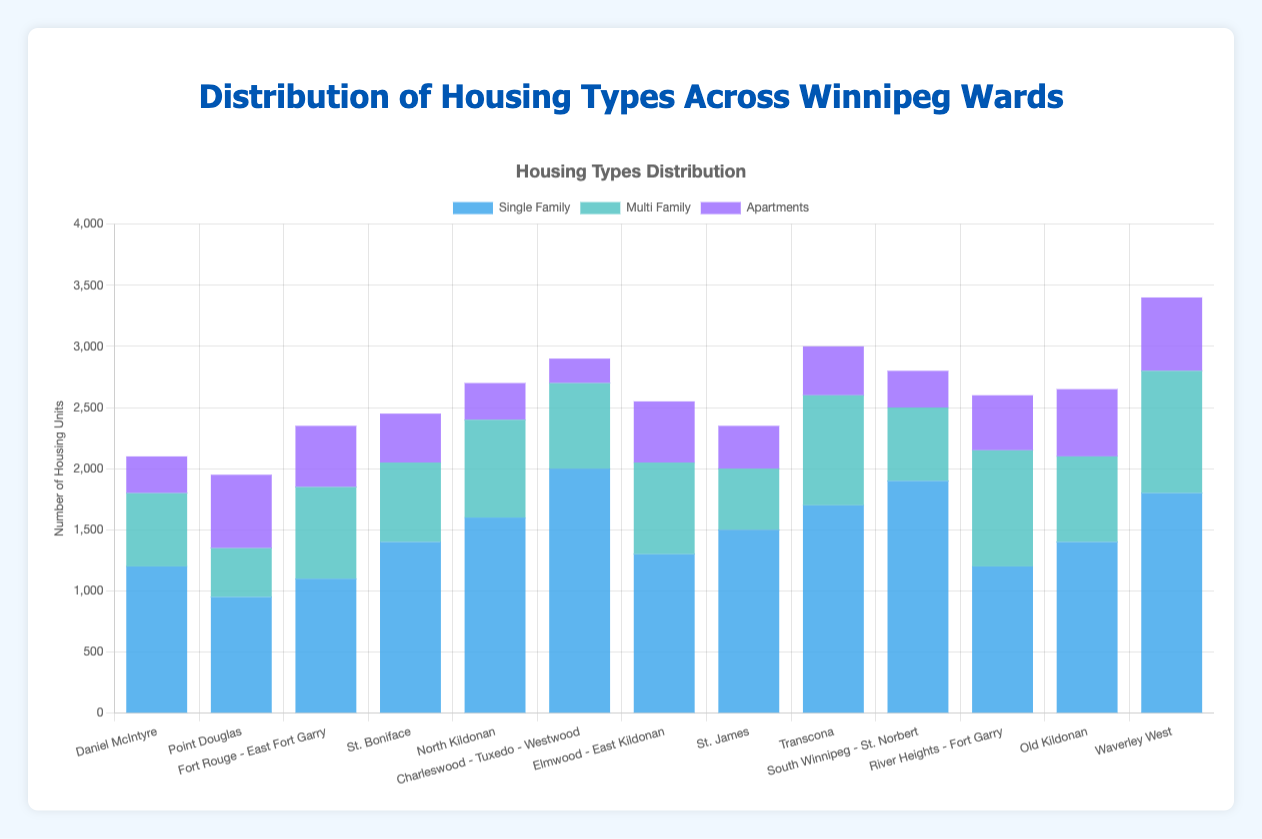Which ward has the highest number of single-family housing units? To answer this, look at the height of the blue bars representing single-family housing units across all wards. The tallest bar corresponds to the highest number.
Answer: Charleswood - Tuxedo - Westwood Which ward has the lowest number of apartments? Assess the height of the purple bars representing apartments in each ward. The shortest bar indicates the lowest number.
Answer: Charleswood - Tuxedo - Westwood What is the total number of multi-family housing units in River Heights - Fort Garry and Waverley West combined? Sum the number of multi-family housing units for both wards: 950 (River Heights - Fort Garry) + 1000 (Waverley West).
Answer: 1950 Which ward has more multi-family units: Elmwood - East Kildonan or St. James? Compare the height of the green bars representing multi-family units for both wards. Elmwood - East Kildonan has 750 and St. James has 500.
Answer: Elmwood - East Kildonan What is the average number of single-family housing units across all wards? Sum the number of single-family units in each ward and divide by the number of wards. The sum is 17750, and there are 13 wards, so 17750 / 13.
Answer: 1365.4 Which wards have an equal number of apartments? Compare the height of the purple bars representing apartments. Look for bars of equal height. Daniel McIntyre, South Winnipeg - St. Norbert, and North Kildonan each have 300 apartments.
Answer: Daniel McIntyre, South Winnipeg - St. Norbert, North Kildonan What is the difference in the number of single-family units between Charleswood - Tuxedo - Westwood and Point Douglas? Subtract the number of single-family units in Point Douglas (950) from Charleswood - Tuxedo - Westwood (2000).
Answer: 1050 Which ward has the most balanced distribution among the three types of housing? Look for the ward where the heights of the blue, green, and purple bars are most similar. River Heights - Fort Garry has relatively balanced distributions: 1200 (single-family), 950 (multi-family), 450 (apartments).
Answer: River Heights - Fort Garry 